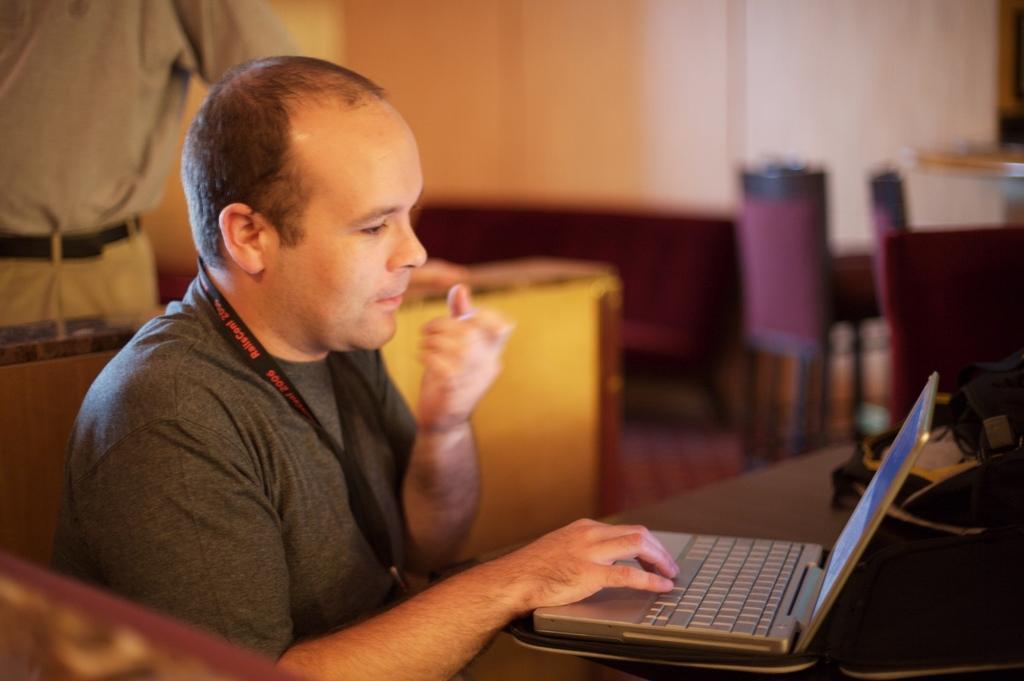How would you summarize this image in a sentence or two? In this image, we can see a man sitting and he is using a laptop, on the left side there is a person standing, we can see the chairs and a wall. 